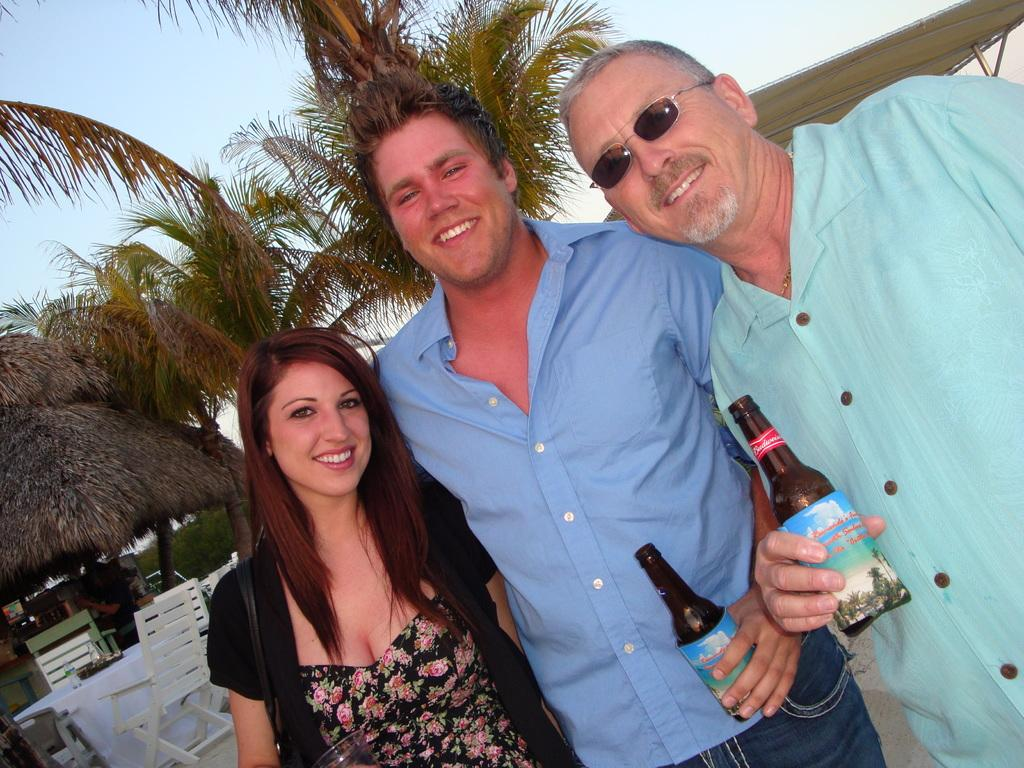How many people are in the image? There are three persons standing in the image. What are the expressions on their faces? The three persons are smiling. What are two of the persons holding? Two of the persons are holding a bottle. What can be seen in the background of the image? There are chairs, objects on a table, trees, and the sky visible in the background of the image. What type of hospital can be seen in the background of the image? There is no hospital present in the image; the background features chairs, objects on a table, trees, and the sky. What route are the three persons taking in the image? The image does not depict a route or any movement; it shows three people standing and smiling. 